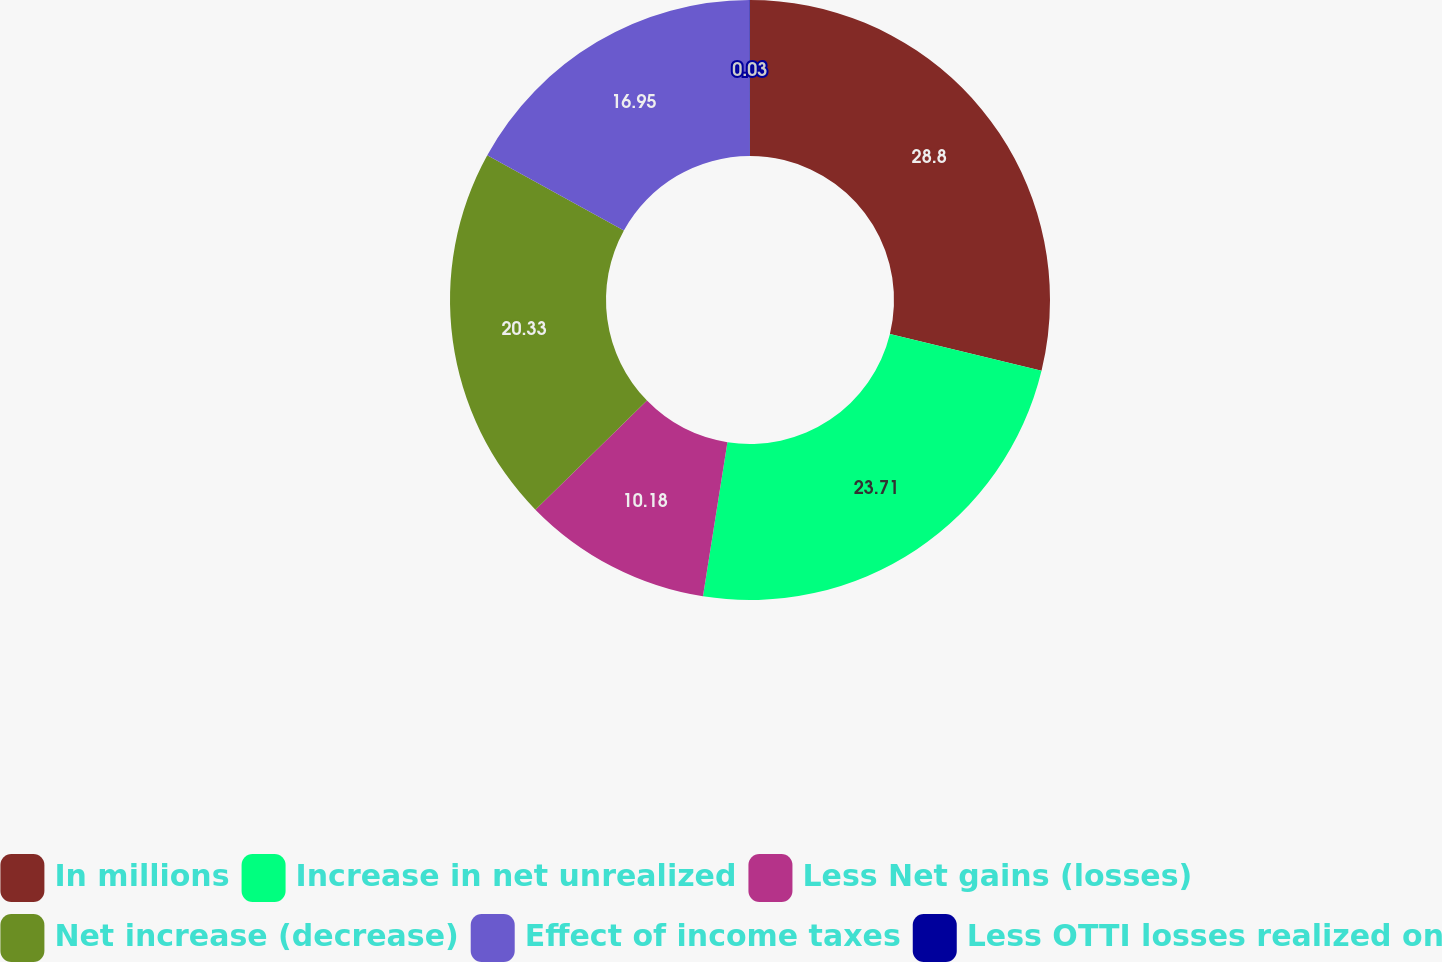<chart> <loc_0><loc_0><loc_500><loc_500><pie_chart><fcel>In millions<fcel>Increase in net unrealized<fcel>Less Net gains (losses)<fcel>Net increase (decrease)<fcel>Effect of income taxes<fcel>Less OTTI losses realized on<nl><fcel>28.79%<fcel>23.71%<fcel>10.18%<fcel>20.33%<fcel>16.95%<fcel>0.03%<nl></chart> 